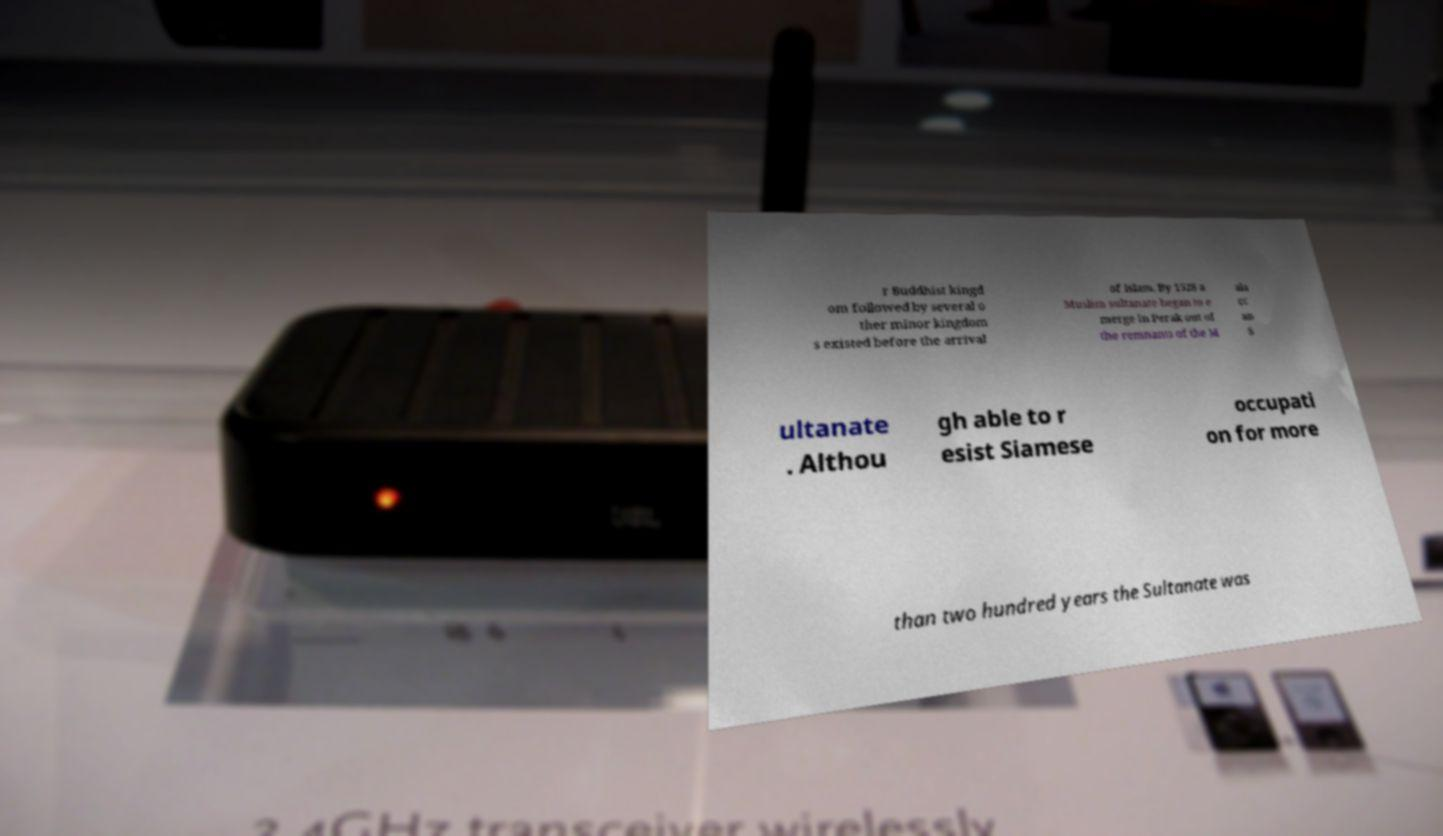Could you extract and type out the text from this image? r Buddhist kingd om followed by several o ther minor kingdom s existed before the arrival of Islam. By 1528 a Muslim sultanate began to e merge in Perak out of the remnants of the M ala cc an S ultanate . Althou gh able to r esist Siamese occupati on for more than two hundred years the Sultanate was 